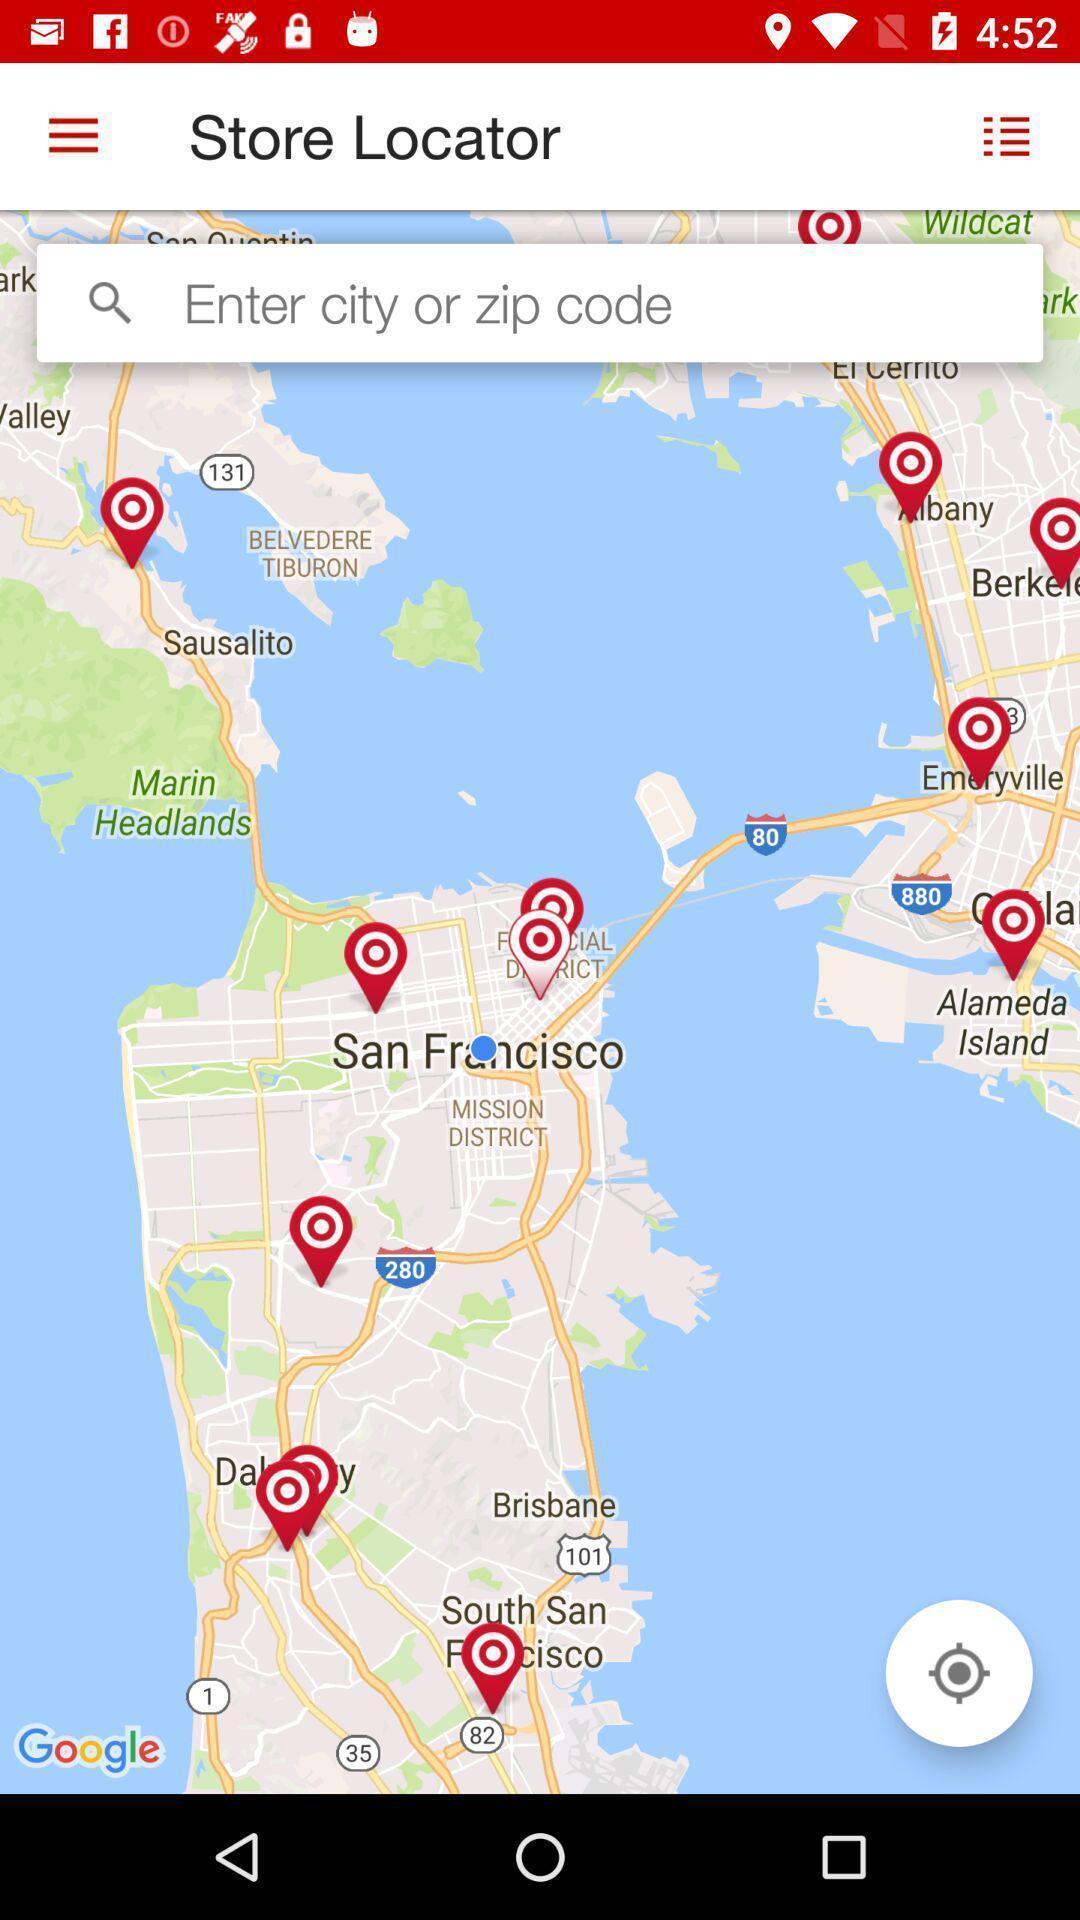Tell me what you see in this picture. Search page for searching a store location. 